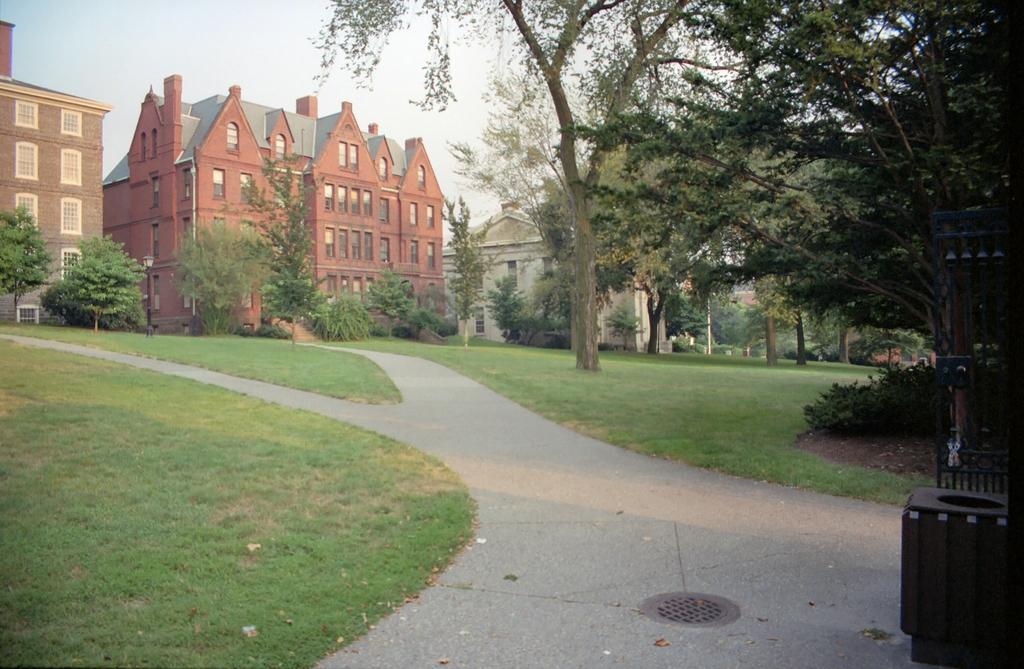In one or two sentences, can you explain what this image depicts? In this image we can see buildings, trees, road, grass, plants and sky. 